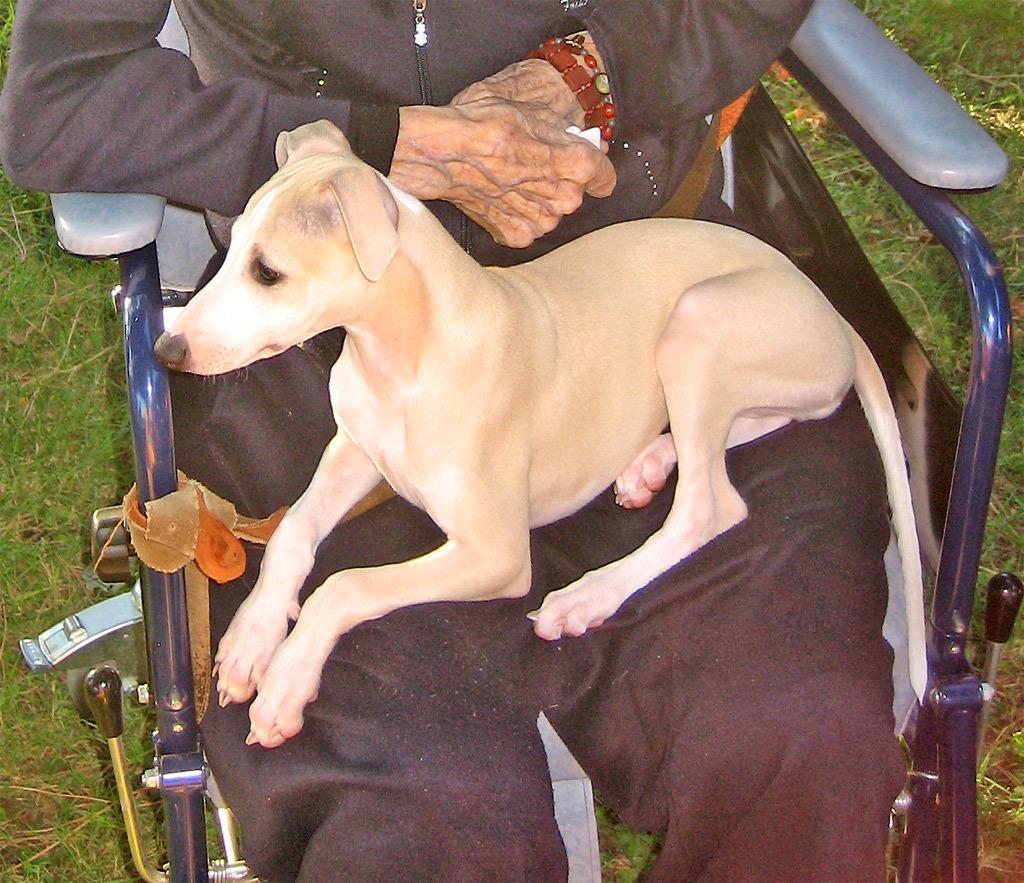In one or two sentences, can you explain what this image depicts? In this image we can see a dog on a person sitting in a chair. 